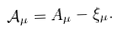<formula> <loc_0><loc_0><loc_500><loc_500>\mathcal { A } _ { \mu } = A _ { \mu } - \xi _ { \mu } .</formula> 